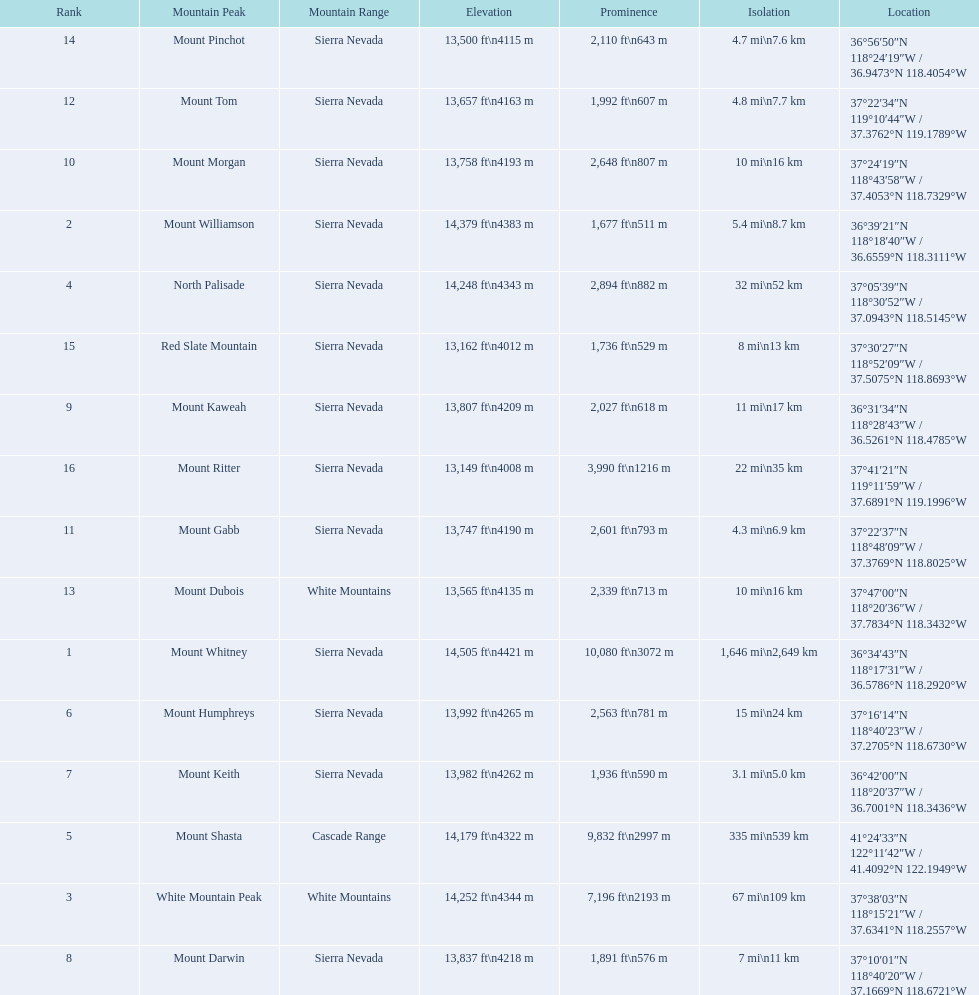Could you parse the entire table? {'header': ['Rank', 'Mountain Peak', 'Mountain Range', 'Elevation', 'Prominence', 'Isolation', 'Location'], 'rows': [['14', 'Mount Pinchot', 'Sierra Nevada', '13,500\xa0ft\\n4115\xa0m', '2,110\xa0ft\\n643\xa0m', '4.7\xa0mi\\n7.6\xa0km', '36°56′50″N 118°24′19″W\ufeff / \ufeff36.9473°N 118.4054°W'], ['12', 'Mount Tom', 'Sierra Nevada', '13,657\xa0ft\\n4163\xa0m', '1,992\xa0ft\\n607\xa0m', '4.8\xa0mi\\n7.7\xa0km', '37°22′34″N 119°10′44″W\ufeff / \ufeff37.3762°N 119.1789°W'], ['10', 'Mount Morgan', 'Sierra Nevada', '13,758\xa0ft\\n4193\xa0m', '2,648\xa0ft\\n807\xa0m', '10\xa0mi\\n16\xa0km', '37°24′19″N 118°43′58″W\ufeff / \ufeff37.4053°N 118.7329°W'], ['2', 'Mount Williamson', 'Sierra Nevada', '14,379\xa0ft\\n4383\xa0m', '1,677\xa0ft\\n511\xa0m', '5.4\xa0mi\\n8.7\xa0km', '36°39′21″N 118°18′40″W\ufeff / \ufeff36.6559°N 118.3111°W'], ['4', 'North Palisade', 'Sierra Nevada', '14,248\xa0ft\\n4343\xa0m', '2,894\xa0ft\\n882\xa0m', '32\xa0mi\\n52\xa0km', '37°05′39″N 118°30′52″W\ufeff / \ufeff37.0943°N 118.5145°W'], ['15', 'Red Slate Mountain', 'Sierra Nevada', '13,162\xa0ft\\n4012\xa0m', '1,736\xa0ft\\n529\xa0m', '8\xa0mi\\n13\xa0km', '37°30′27″N 118°52′09″W\ufeff / \ufeff37.5075°N 118.8693°W'], ['9', 'Mount Kaweah', 'Sierra Nevada', '13,807\xa0ft\\n4209\xa0m', '2,027\xa0ft\\n618\xa0m', '11\xa0mi\\n17\xa0km', '36°31′34″N 118°28′43″W\ufeff / \ufeff36.5261°N 118.4785°W'], ['16', 'Mount Ritter', 'Sierra Nevada', '13,149\xa0ft\\n4008\xa0m', '3,990\xa0ft\\n1216\xa0m', '22\xa0mi\\n35\xa0km', '37°41′21″N 119°11′59″W\ufeff / \ufeff37.6891°N 119.1996°W'], ['11', 'Mount Gabb', 'Sierra Nevada', '13,747\xa0ft\\n4190\xa0m', '2,601\xa0ft\\n793\xa0m', '4.3\xa0mi\\n6.9\xa0km', '37°22′37″N 118°48′09″W\ufeff / \ufeff37.3769°N 118.8025°W'], ['13', 'Mount Dubois', 'White Mountains', '13,565\xa0ft\\n4135\xa0m', '2,339\xa0ft\\n713\xa0m', '10\xa0mi\\n16\xa0km', '37°47′00″N 118°20′36″W\ufeff / \ufeff37.7834°N 118.3432°W'], ['1', 'Mount Whitney', 'Sierra Nevada', '14,505\xa0ft\\n4421\xa0m', '10,080\xa0ft\\n3072\xa0m', '1,646\xa0mi\\n2,649\xa0km', '36°34′43″N 118°17′31″W\ufeff / \ufeff36.5786°N 118.2920°W'], ['6', 'Mount Humphreys', 'Sierra Nevada', '13,992\xa0ft\\n4265\xa0m', '2,563\xa0ft\\n781\xa0m', '15\xa0mi\\n24\xa0km', '37°16′14″N 118°40′23″W\ufeff / \ufeff37.2705°N 118.6730°W'], ['7', 'Mount Keith', 'Sierra Nevada', '13,982\xa0ft\\n4262\xa0m', '1,936\xa0ft\\n590\xa0m', '3.1\xa0mi\\n5.0\xa0km', '36°42′00″N 118°20′37″W\ufeff / \ufeff36.7001°N 118.3436°W'], ['5', 'Mount Shasta', 'Cascade Range', '14,179\xa0ft\\n4322\xa0m', '9,832\xa0ft\\n2997\xa0m', '335\xa0mi\\n539\xa0km', '41°24′33″N 122°11′42″W\ufeff / \ufeff41.4092°N 122.1949°W'], ['3', 'White Mountain Peak', 'White Mountains', '14,252\xa0ft\\n4344\xa0m', '7,196\xa0ft\\n2193\xa0m', '67\xa0mi\\n109\xa0km', '37°38′03″N 118°15′21″W\ufeff / \ufeff37.6341°N 118.2557°W'], ['8', 'Mount Darwin', 'Sierra Nevada', '13,837\xa0ft\\n4218\xa0m', '1,891\xa0ft\\n576\xa0m', '7\xa0mi\\n11\xa0km', '37°10′01″N 118°40′20″W\ufeff / \ufeff37.1669°N 118.6721°W']]} Which mountain peak is in the white mountains range? White Mountain Peak. Which mountain is in the sierra nevada range? Mount Whitney. Which mountain is the only one in the cascade range? Mount Shasta. 